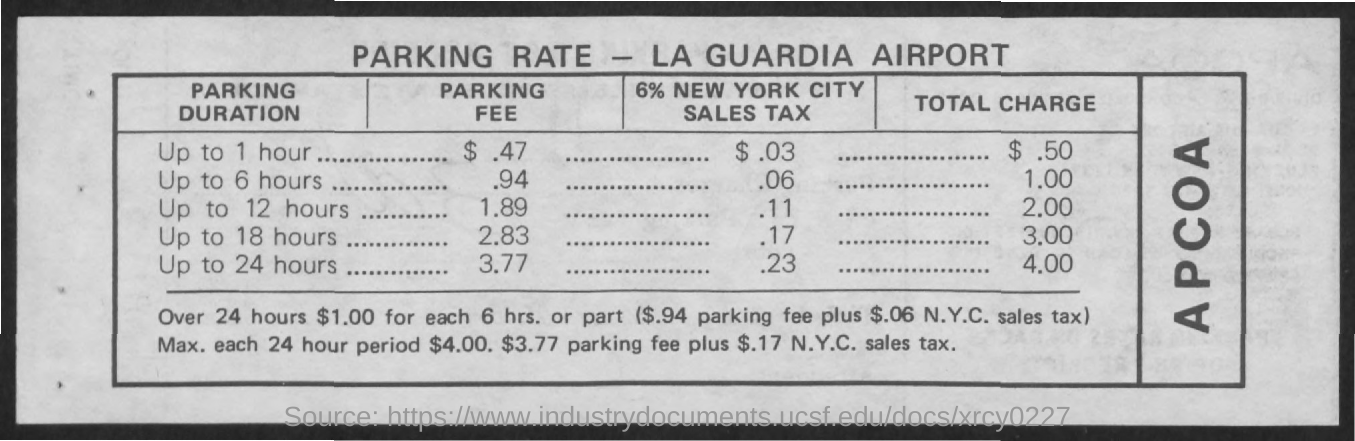What is the Title of the document?
Provide a succinct answer. PARKING RATE LA GUARDIA AIRPORT. What is the "Parking Fee" for up to 1 hour?
Give a very brief answer. .47. What is the "Parking Fee" for up to 6 hours?
Give a very brief answer. .94. What is the "Parking Fee" for up to 12 hours?
Your response must be concise. 1.89. What is the "Parking Fee" for up to 18 hours?
Your answer should be compact. 2.83. What is the "Parking Fee" for up to 24 hours?
Make the answer very short. 3.77. What is the "Total Charge" for up to 1 hour?
Provide a short and direct response. $.50. What is the "Total Charge" for up to 6 hours?
Give a very brief answer. 1.00. What is the "Total Charge" for up to 12 hours?
Your answer should be compact. 2.00. What is the "Total Charge" for up to 18 hours?
Give a very brief answer. 3.00. 